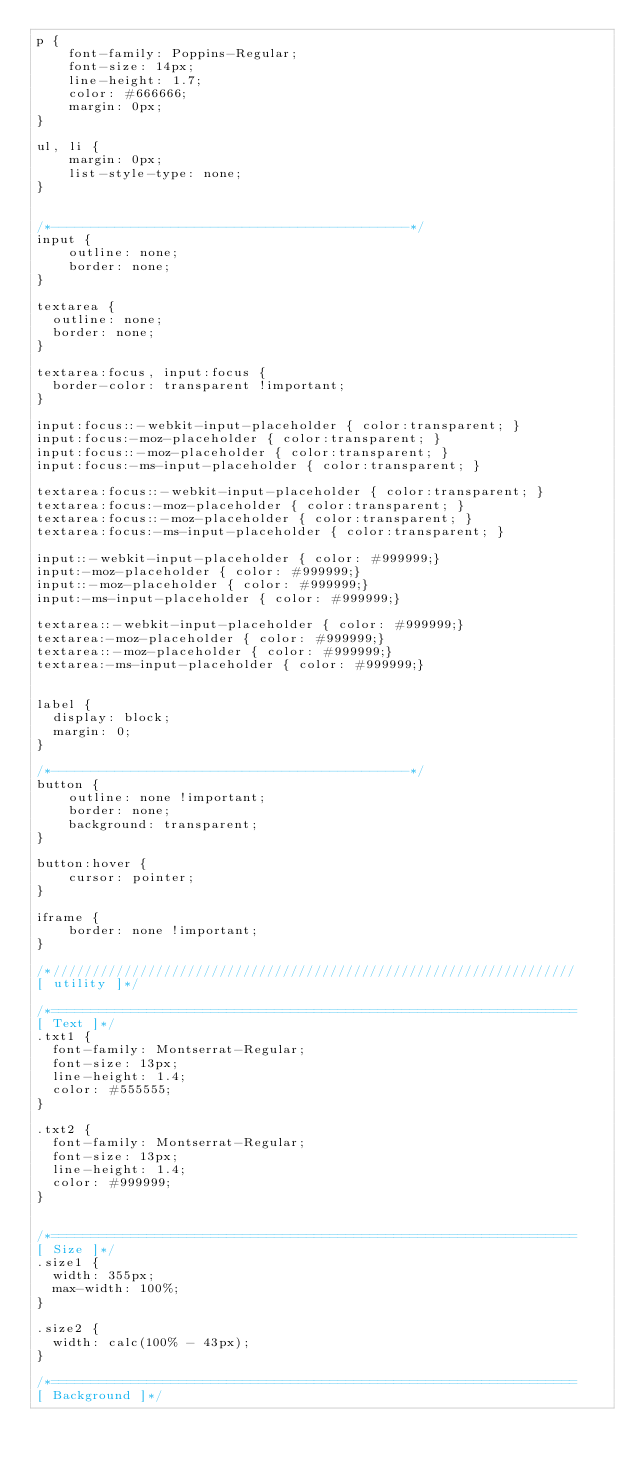Convert code to text. <code><loc_0><loc_0><loc_500><loc_500><_CSS_>p {
	font-family: Poppins-Regular;
	font-size: 14px;
	line-height: 1.7;
	color: #666666;
	margin: 0px;
}

ul, li {
	margin: 0px;
	list-style-type: none;
}


/*---------------------------------------------*/
input {
	outline: none;
	border: none;
}

textarea {
  outline: none;
  border: none;
}

textarea:focus, input:focus {
  border-color: transparent !important;
}

input:focus::-webkit-input-placeholder { color:transparent; }
input:focus:-moz-placeholder { color:transparent; }
input:focus::-moz-placeholder { color:transparent; }
input:focus:-ms-input-placeholder { color:transparent; }

textarea:focus::-webkit-input-placeholder { color:transparent; }
textarea:focus:-moz-placeholder { color:transparent; }
textarea:focus::-moz-placeholder { color:transparent; }
textarea:focus:-ms-input-placeholder { color:transparent; }

input::-webkit-input-placeholder { color: #999999;}
input:-moz-placeholder { color: #999999;}
input::-moz-placeholder { color: #999999;}
input:-ms-input-placeholder { color: #999999;}

textarea::-webkit-input-placeholder { color: #999999;}
textarea:-moz-placeholder { color: #999999;}
textarea::-moz-placeholder { color: #999999;}
textarea:-ms-input-placeholder { color: #999999;}


label {
  display: block;
  margin: 0;
}

/*---------------------------------------------*/
button {
	outline: none !important;
	border: none;
	background: transparent;
}

button:hover {
	cursor: pointer;
}

iframe {
	border: none !important;
}

/*//////////////////////////////////////////////////////////////////
[ utility ]*/

/*==================================================================
[ Text ]*/
.txt1 {
  font-family: Montserrat-Regular;
  font-size: 13px;
  line-height: 1.4;
  color: #555555;
}

.txt2 {
  font-family: Montserrat-Regular;
  font-size: 13px;
  line-height: 1.4;
  color: #999999;
}


/*==================================================================
[ Size ]*/
.size1 {
  width: 355px;
  max-width: 100%;
}

.size2 {
  width: calc(100% - 43px);
}

/*==================================================================
[ Background ]*/</code> 